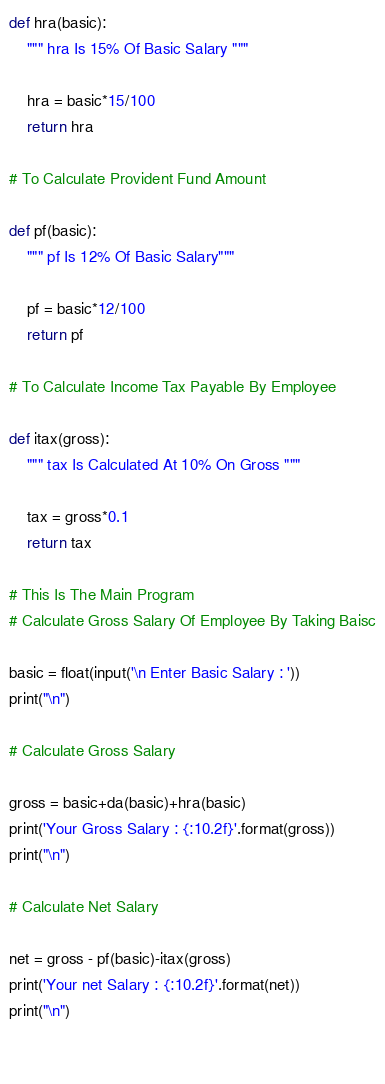<code> <loc_0><loc_0><loc_500><loc_500><_Python_>
def hra(basic):
    """ hra Is 15% Of Basic Salary """
    
    hra = basic*15/100
    return hra

# To Calculate Provident Fund Amount

def pf(basic):
    """ pf Is 12% Of Basic Salary"""
    
    pf = basic*12/100
    return pf

# To Calculate Income Tax Payable By Employee

def itax(gross):
    """ tax Is Calculated At 10% On Gross """
    
    tax = gross*0.1
    return tax

# This Is The Main Program
# Calculate Gross Salary Of Employee By Taking Baisc

basic = float(input('\n Enter Basic Salary : '))
print("\n")

# Calculate Gross Salary

gross = basic+da(basic)+hra(basic)
print('Your Gross Salary : {:10.2f}'.format(gross))
print("\n")

# Calculate Net Salary

net = gross - pf(basic)-itax(gross)
print('Your net Salary : {:10.2f}'.format(net))
print("\n")

  </code> 